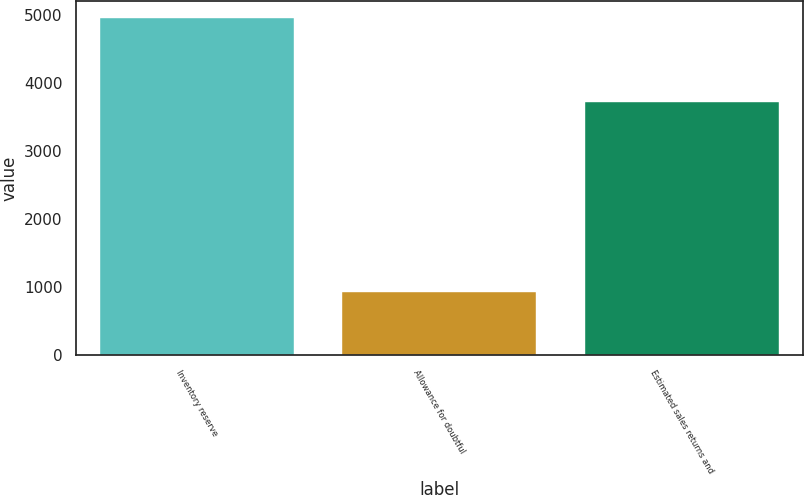Convert chart. <chart><loc_0><loc_0><loc_500><loc_500><bar_chart><fcel>Inventory reserve<fcel>Allowance for doubtful<fcel>Estimated sales returns and<nl><fcel>4970<fcel>933<fcel>3731<nl></chart> 